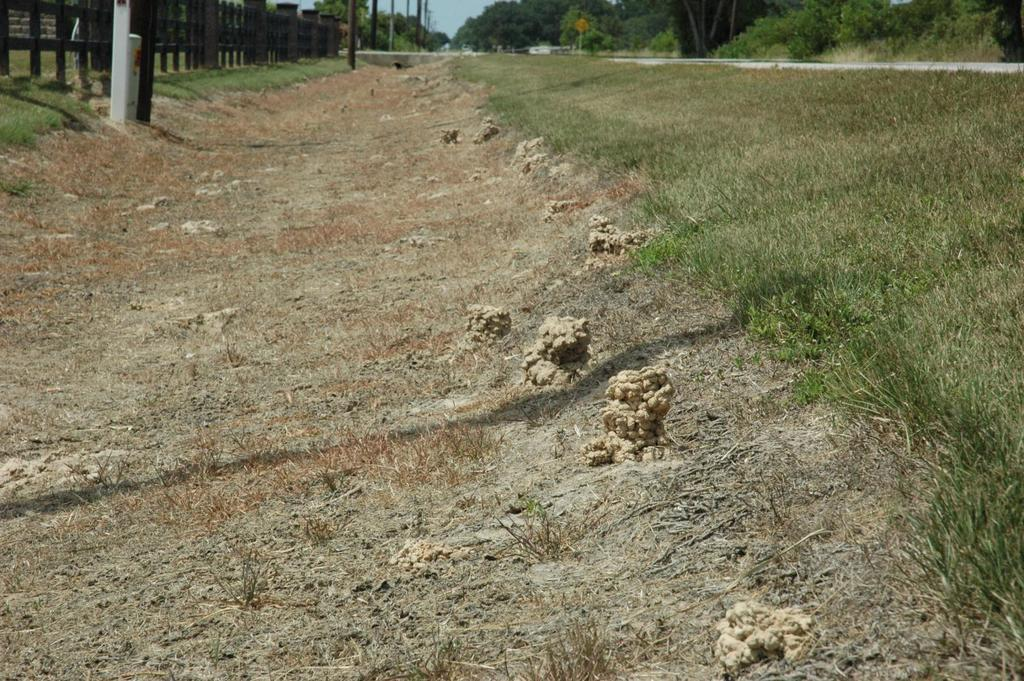What type of terrain is depicted in the image? There is a land in the image. What can be found on the land? There is soil on the land, as well as grass on the right side, a fence on the left side, and poles in the middle. What type of celery is growing on the left side of the land? There is no celery present in the image; the left side of the land features a fence. Can you see any blood on the grass in the image? There is no blood visible in the image; it features a land with soil, grass, a fence, and poles. 